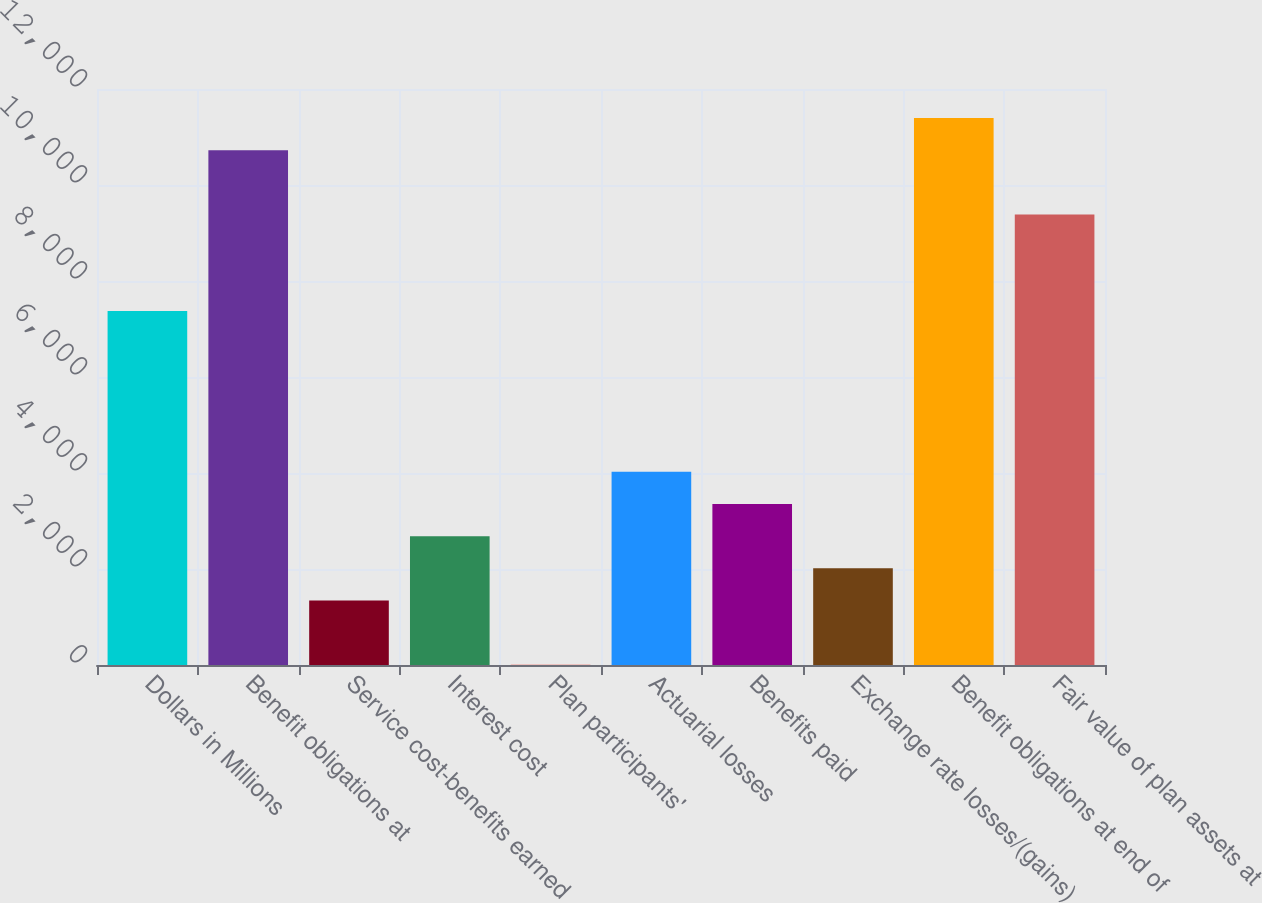Convert chart to OTSL. <chart><loc_0><loc_0><loc_500><loc_500><bar_chart><fcel>Dollars in Millions<fcel>Benefit obligations at<fcel>Service cost-benefits earned<fcel>Interest cost<fcel>Plan participants'<fcel>Actuarial losses<fcel>Benefits paid<fcel>Exchange rate losses/(gains)<fcel>Benefit obligations at end of<fcel>Fair value of plan assets at<nl><fcel>7374.1<fcel>10724.6<fcel>1343.2<fcel>2683.4<fcel>3<fcel>4023.6<fcel>3353.5<fcel>2013.3<fcel>11394.7<fcel>9384.4<nl></chart> 